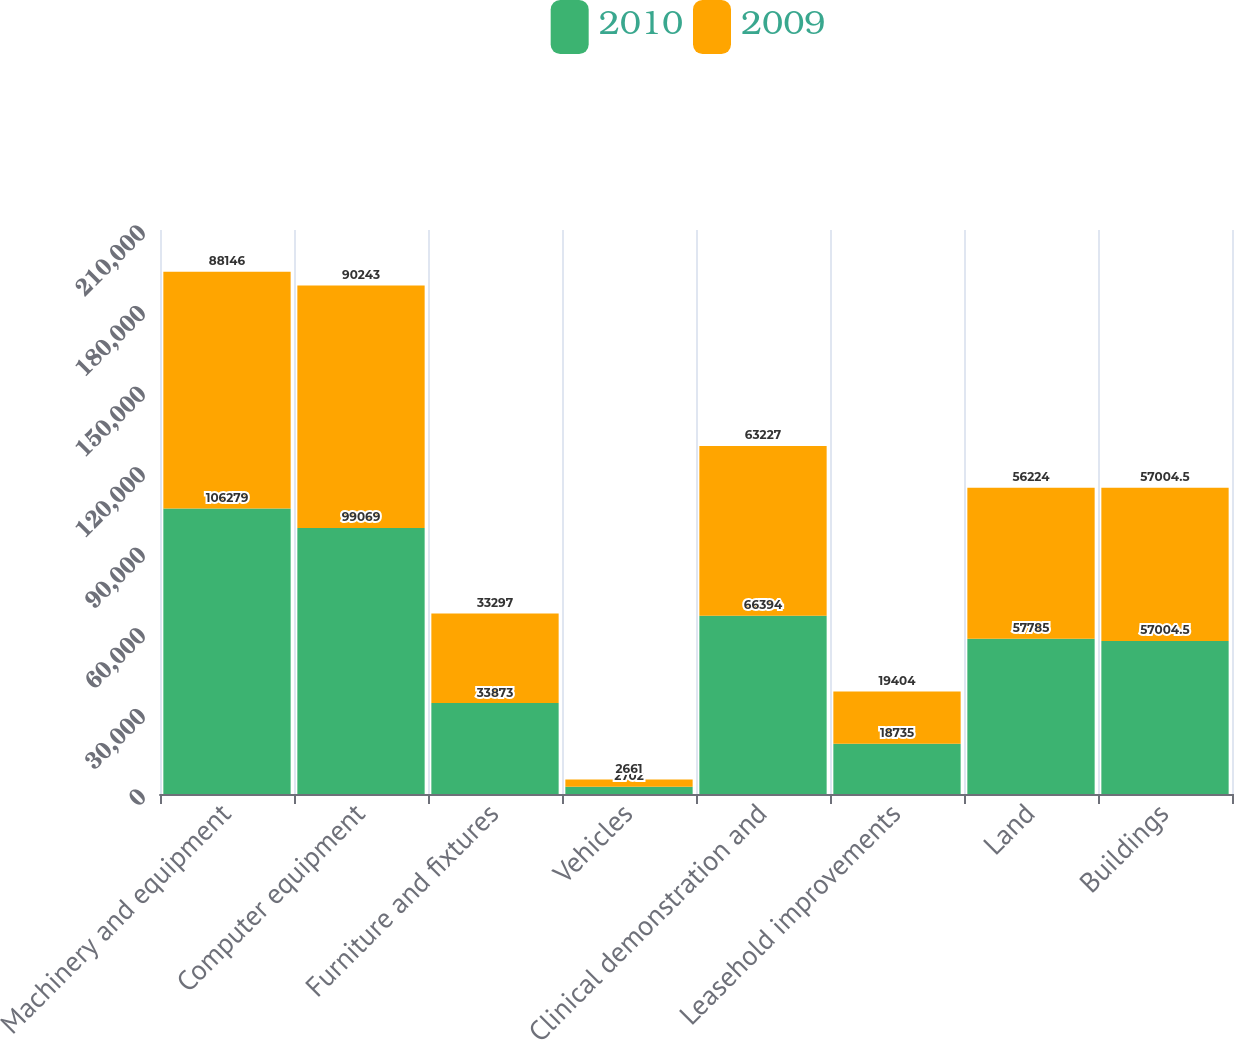<chart> <loc_0><loc_0><loc_500><loc_500><stacked_bar_chart><ecel><fcel>Machinery and equipment<fcel>Computer equipment<fcel>Furniture and fixtures<fcel>Vehicles<fcel>Clinical demonstration and<fcel>Leasehold improvements<fcel>Land<fcel>Buildings<nl><fcel>2010<fcel>106279<fcel>99069<fcel>33873<fcel>2702<fcel>66394<fcel>18735<fcel>57785<fcel>57004.5<nl><fcel>2009<fcel>88146<fcel>90243<fcel>33297<fcel>2661<fcel>63227<fcel>19404<fcel>56224<fcel>57004.5<nl></chart> 